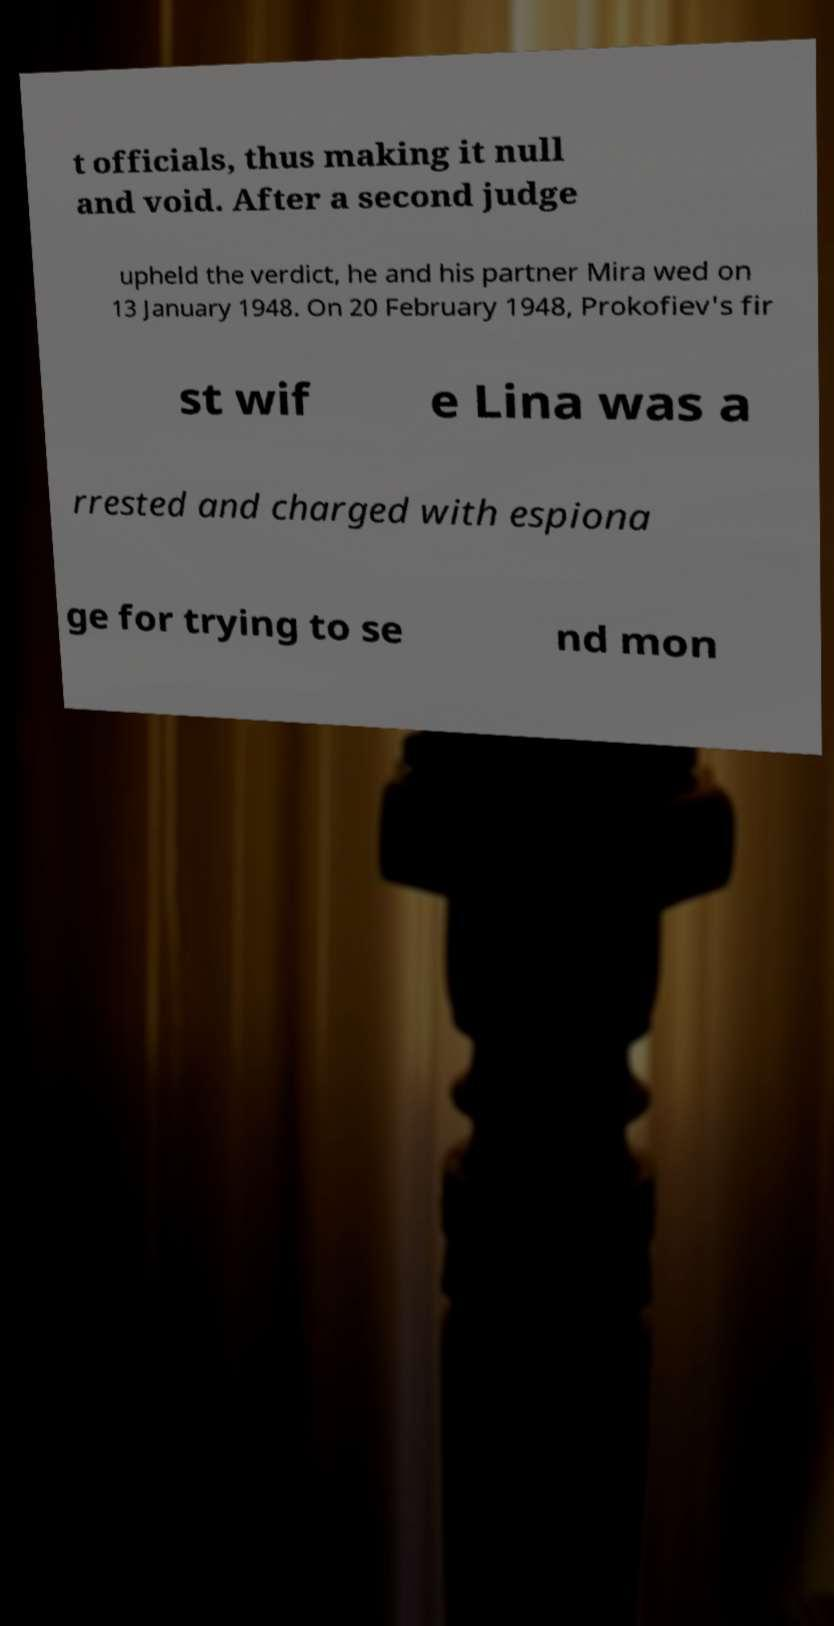Please identify and transcribe the text found in this image. t officials, thus making it null and void. After a second judge upheld the verdict, he and his partner Mira wed on 13 January 1948. On 20 February 1948, Prokofiev's fir st wif e Lina was a rrested and charged with espiona ge for trying to se nd mon 